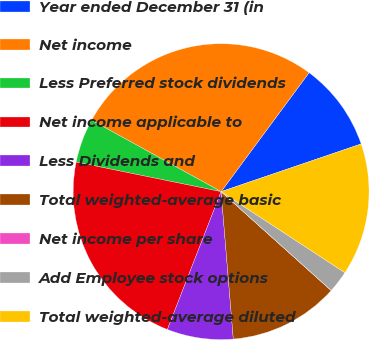Convert chart. <chart><loc_0><loc_0><loc_500><loc_500><pie_chart><fcel>Year ended December 31 (in<fcel>Net income<fcel>Less Preferred stock dividends<fcel>Net income applicable to<fcel>Less Dividends and<fcel>Total weighted-average basic<fcel>Net income per share<fcel>Add Employee stock options<fcel>Total weighted-average diluted<nl><fcel>9.64%<fcel>27.11%<fcel>4.82%<fcel>22.29%<fcel>7.23%<fcel>12.04%<fcel>0.01%<fcel>2.41%<fcel>14.45%<nl></chart> 